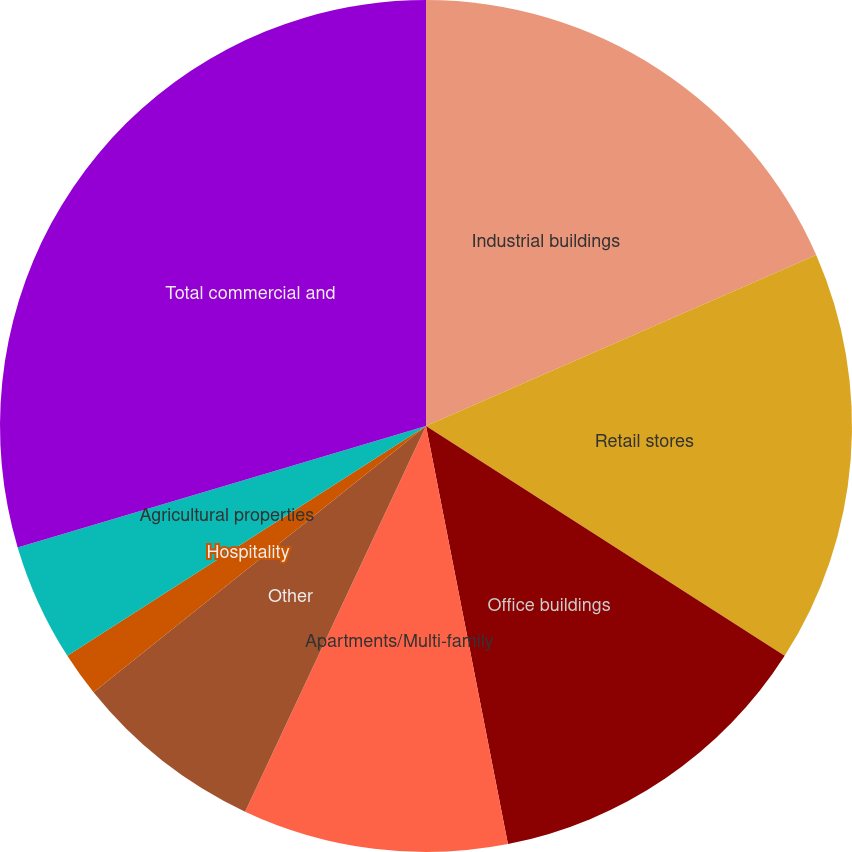<chart> <loc_0><loc_0><loc_500><loc_500><pie_chart><fcel>Industrial buildings<fcel>Retail stores<fcel>Office buildings<fcel>Apartments/Multi-family<fcel>Other<fcel>Hospitality<fcel>Agricultural properties<fcel>Total commercial and<nl><fcel>18.43%<fcel>15.64%<fcel>12.85%<fcel>10.06%<fcel>7.27%<fcel>1.68%<fcel>4.47%<fcel>29.6%<nl></chart> 